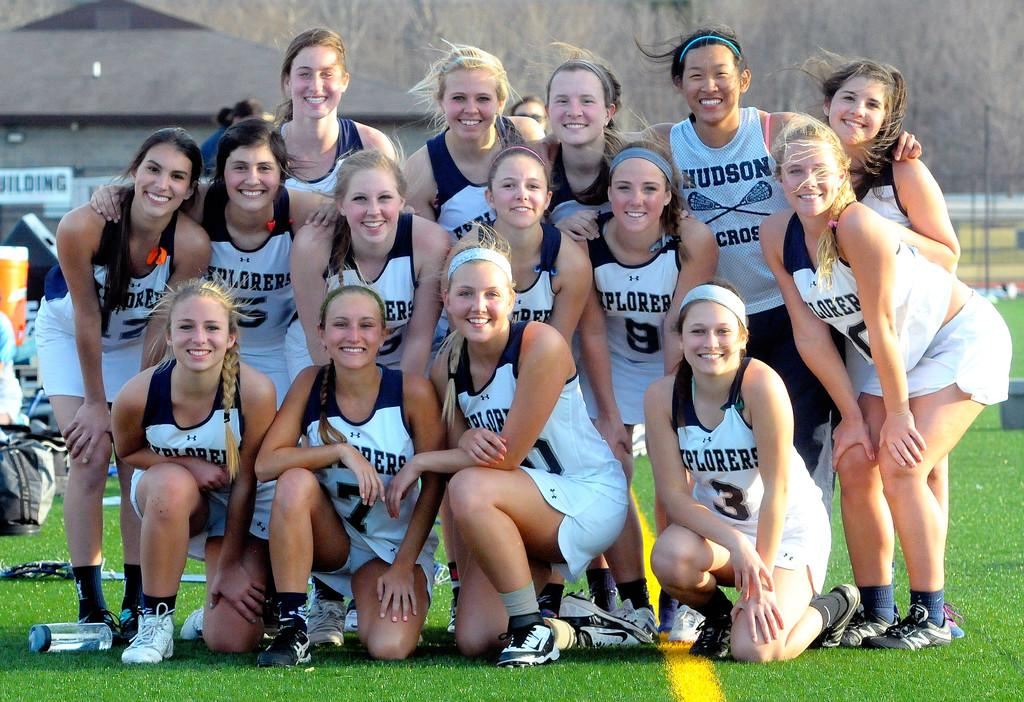<image>
Relay a brief, clear account of the picture shown. The girls with the green headband has a shirt that says Hudson on it 